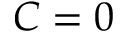Convert formula to latex. <formula><loc_0><loc_0><loc_500><loc_500>C = 0</formula> 